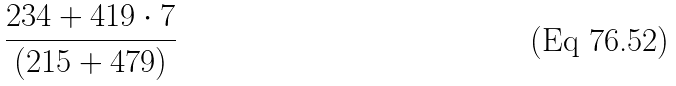Convert formula to latex. <formula><loc_0><loc_0><loc_500><loc_500>\frac { 2 3 4 + 4 1 9 \cdot 7 } { ( 2 1 5 + 4 7 9 ) }</formula> 